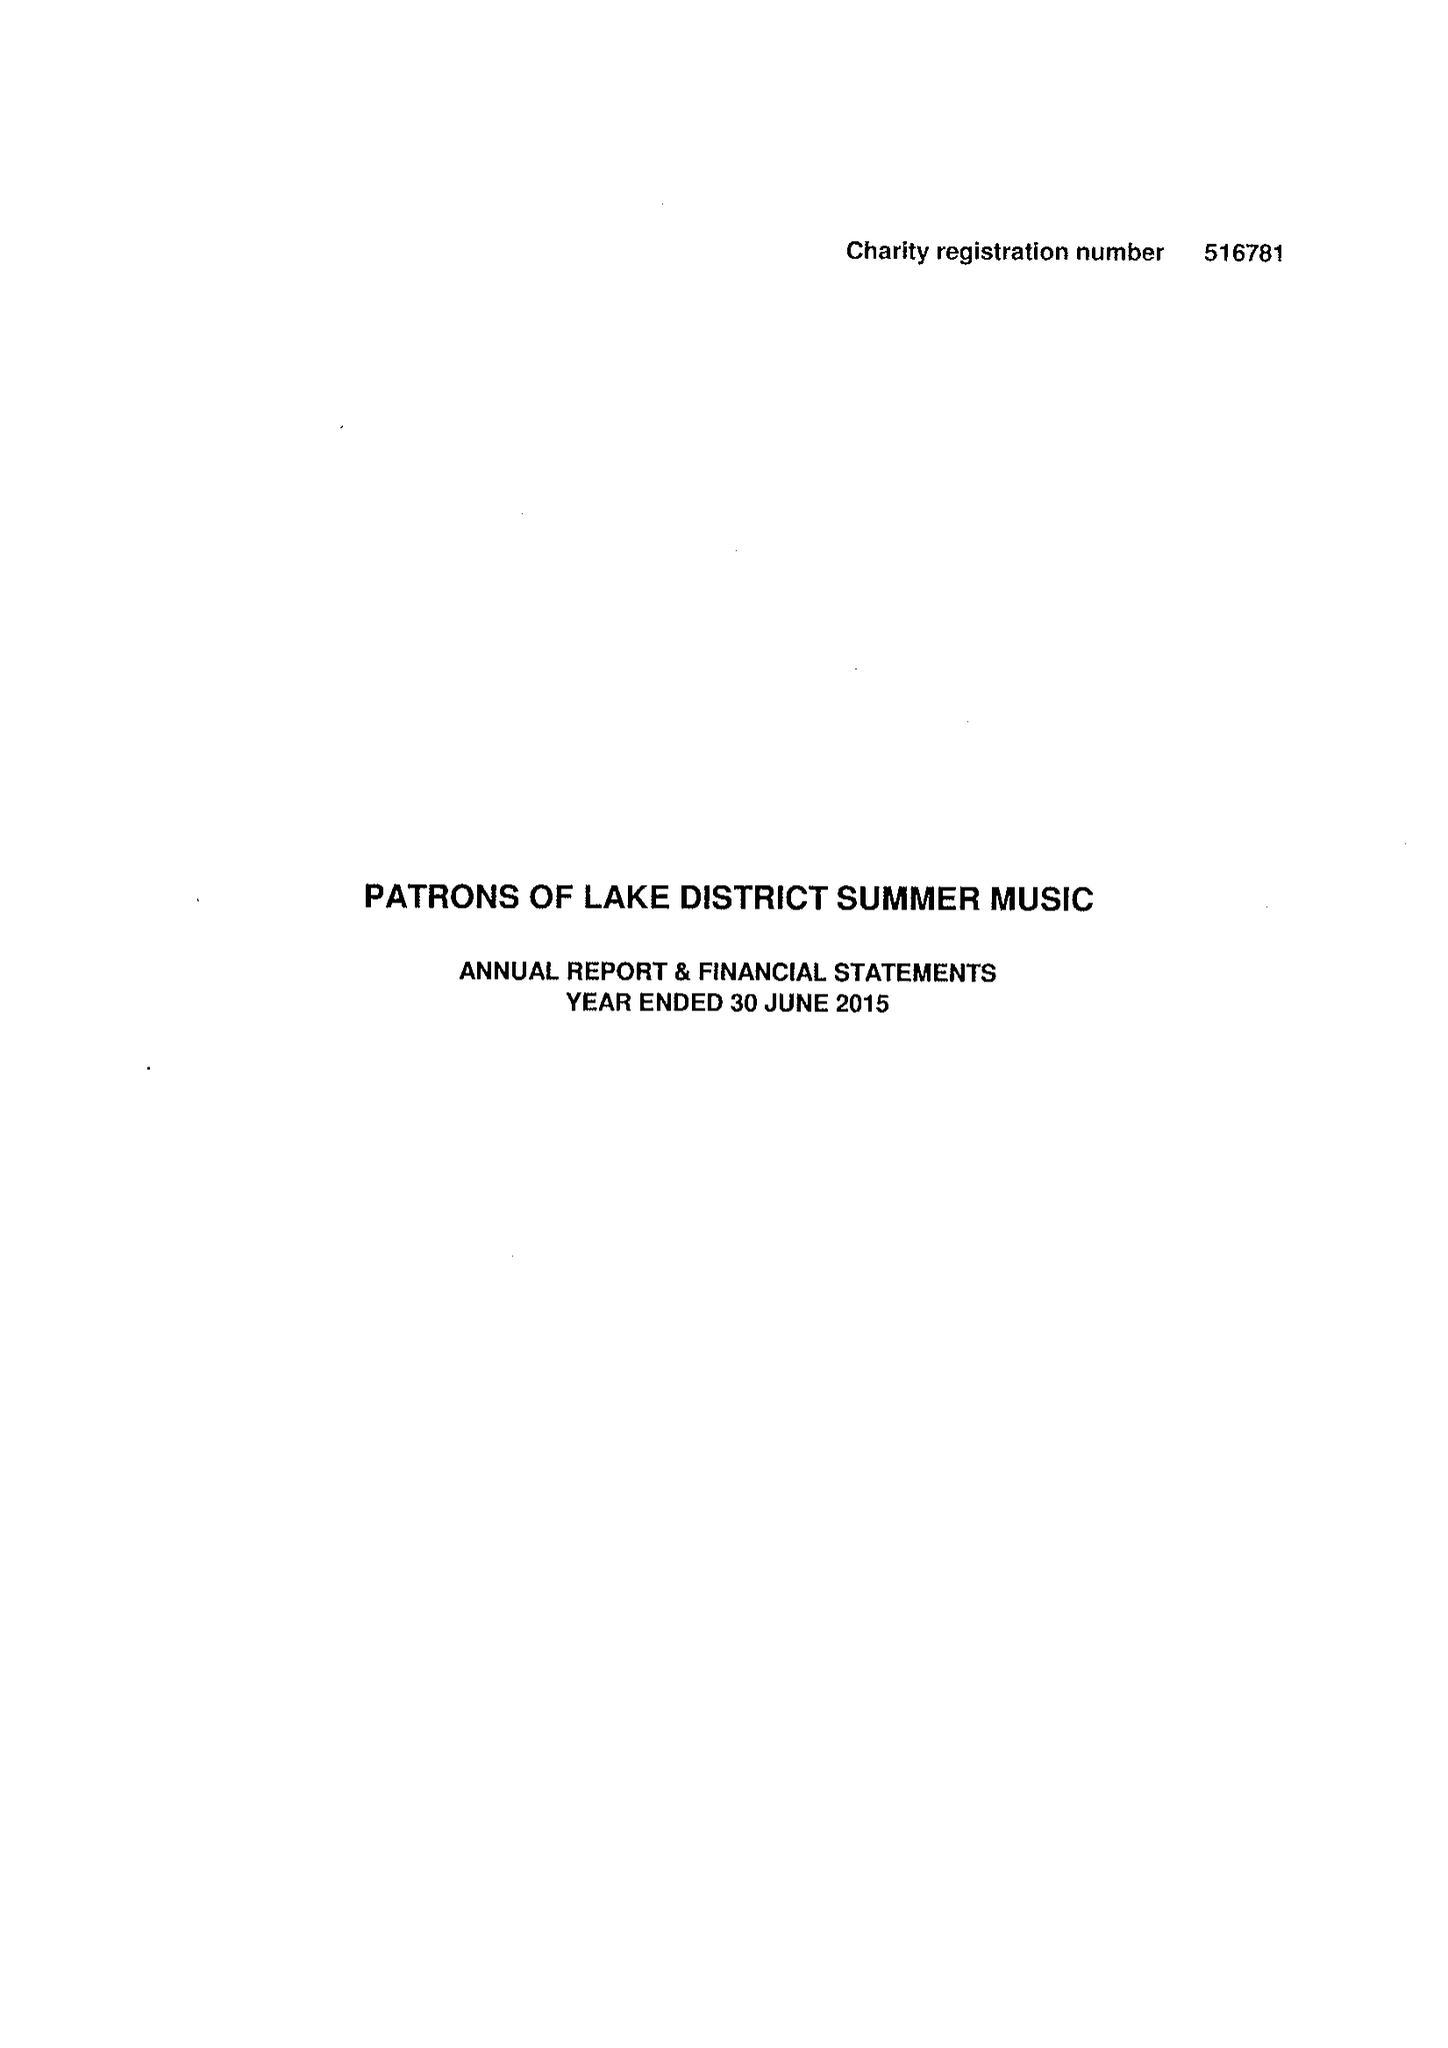What is the value for the charity_name?
Answer the question using a single word or phrase. Patrons Of Lake District Summer Music 